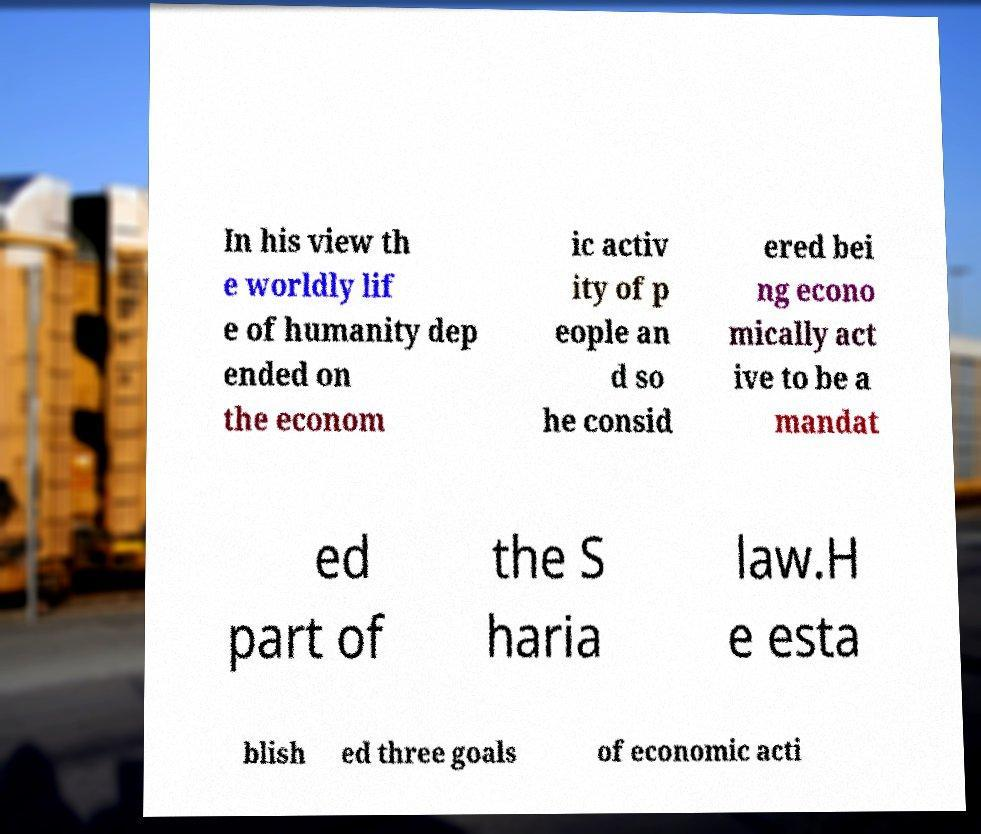What messages or text are displayed in this image? I need them in a readable, typed format. In his view th e worldly lif e of humanity dep ended on the econom ic activ ity of p eople an d so he consid ered bei ng econo mically act ive to be a mandat ed part of the S haria law.H e esta blish ed three goals of economic acti 